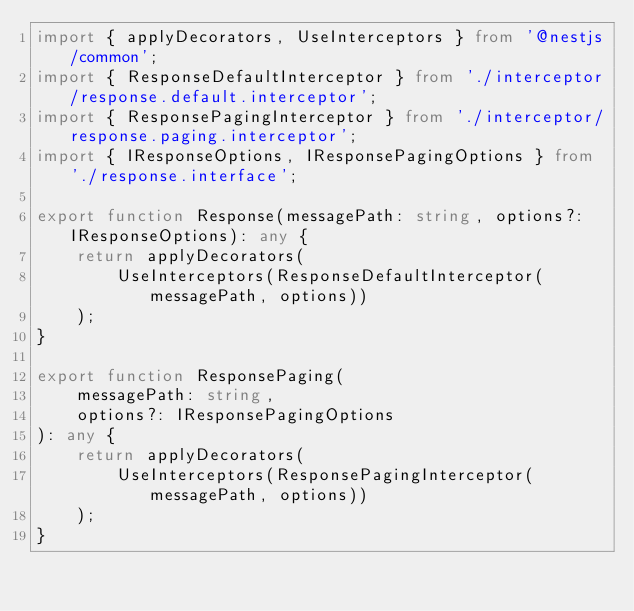Convert code to text. <code><loc_0><loc_0><loc_500><loc_500><_TypeScript_>import { applyDecorators, UseInterceptors } from '@nestjs/common';
import { ResponseDefaultInterceptor } from './interceptor/response.default.interceptor';
import { ResponsePagingInterceptor } from './interceptor/response.paging.interceptor';
import { IResponseOptions, IResponsePagingOptions } from './response.interface';

export function Response(messagePath: string, options?: IResponseOptions): any {
    return applyDecorators(
        UseInterceptors(ResponseDefaultInterceptor(messagePath, options))
    );
}

export function ResponsePaging(
    messagePath: string,
    options?: IResponsePagingOptions
): any {
    return applyDecorators(
        UseInterceptors(ResponsePagingInterceptor(messagePath, options))
    );
}
</code> 